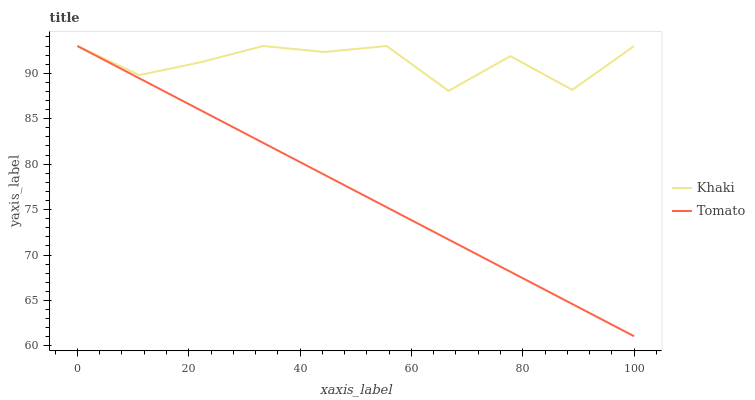Does Tomato have the minimum area under the curve?
Answer yes or no. Yes. Does Khaki have the maximum area under the curve?
Answer yes or no. Yes. Does Khaki have the minimum area under the curve?
Answer yes or no. No. Is Tomato the smoothest?
Answer yes or no. Yes. Is Khaki the roughest?
Answer yes or no. Yes. Is Khaki the smoothest?
Answer yes or no. No. Does Khaki have the lowest value?
Answer yes or no. No. 